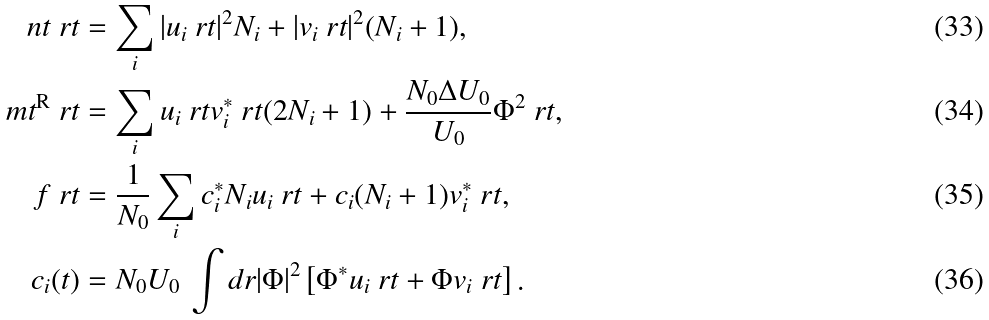<formula> <loc_0><loc_0><loc_500><loc_500>\ n t \ r t & = \sum _ { i } | u _ { i } \ r t | ^ { 2 } N _ { i } + | v _ { i } \ r t | ^ { 2 } ( N _ { i } + 1 ) , \\ \ m t ^ { \text {R} } \ r t & = \sum _ { i } u _ { i } \ r t v _ { i } ^ { * } \ r t ( 2 N _ { i } + 1 ) + \frac { N _ { 0 } \Delta U _ { 0 } } { U _ { 0 } } \Phi ^ { 2 } \ r t , \\ f \ r t & = \frac { 1 } { N _ { 0 } } \sum _ { i } c _ { i } ^ { * } N _ { i } u _ { i } \ r t + c _ { i } ( N _ { i } + 1 ) v _ { i } ^ { * } \ r t , \\ c _ { i } ( t ) & = N _ { 0 } U _ { 0 } \, \int d r | \Phi | ^ { 2 } \left [ \Phi ^ { * } u _ { i } \ r t + \Phi v _ { i } \ r t \right ] .</formula> 